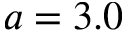<formula> <loc_0><loc_0><loc_500><loc_500>a = 3 . 0</formula> 